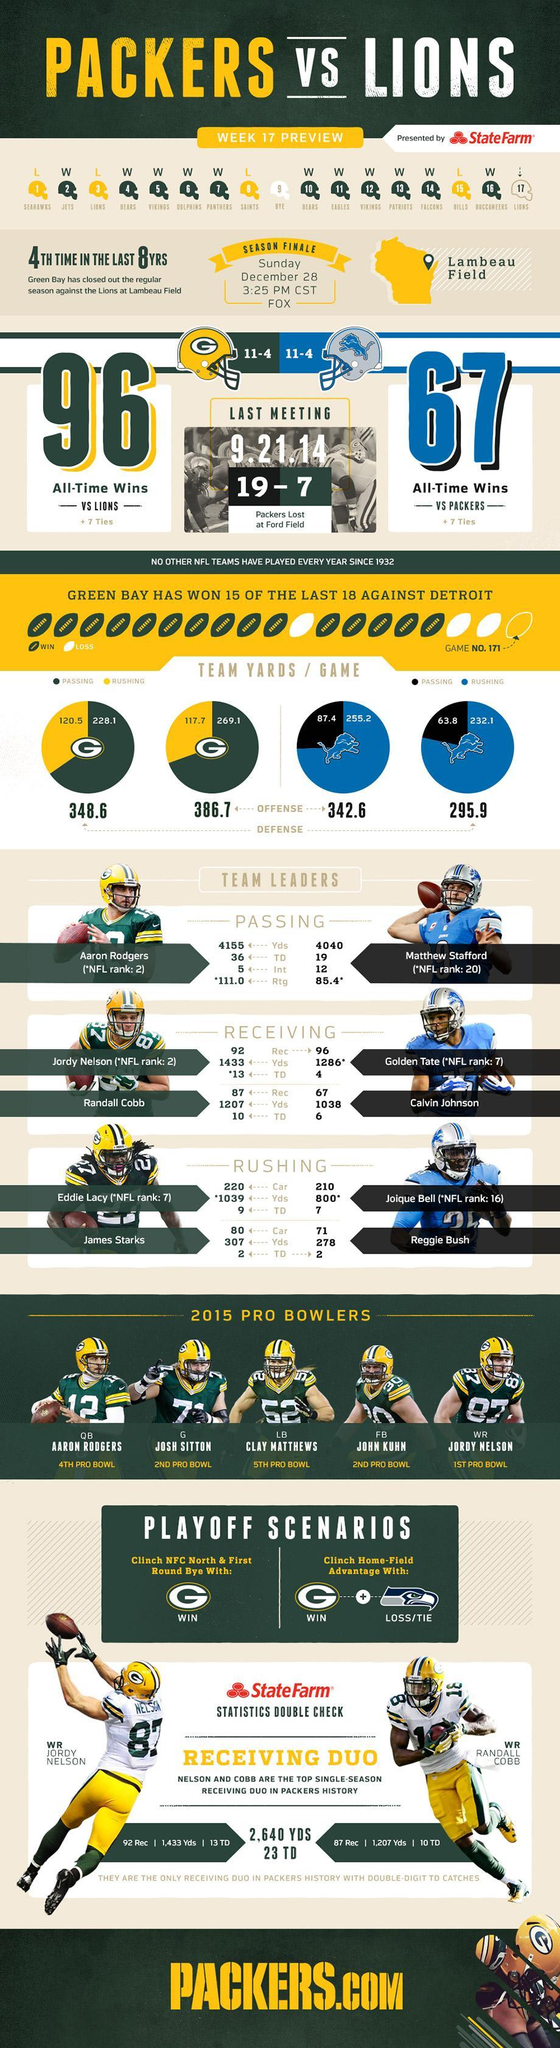Which player from Detroit Lions is ranked sixteenth on the National Football League ?
Answer the question with a short phrase. Joique Bell How many games did Green Bay Packers win until week 17 ? 11 What is the name of the wide receiver in jersey 87? Jordy Nelson What is the defensive rushing score of the team Green Bay Packers? 120.5 Who is the quarterback placed on the left of Josh Sitton? Aaron Rodgers What is the offensive passing score of the team Detroit Lions ? 87.4 How many games has Green Bay Packers lost until week 17 ? 4 Who is the player with the jersey number 87? Jordy Nelson What is the defensive rushing score of the team Detroit Lions ? 232.1 What is the offensive passing score of the team Green Bay Packers? 269.1 